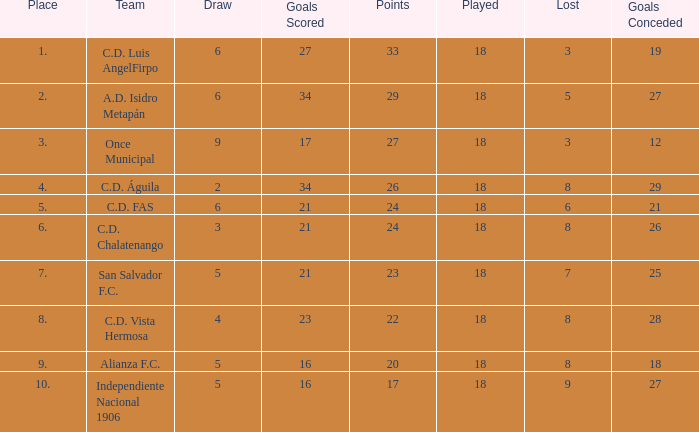How many points were in a game that had a lost of 5, greater than place 2, and 27 goals conceded? 0.0. 